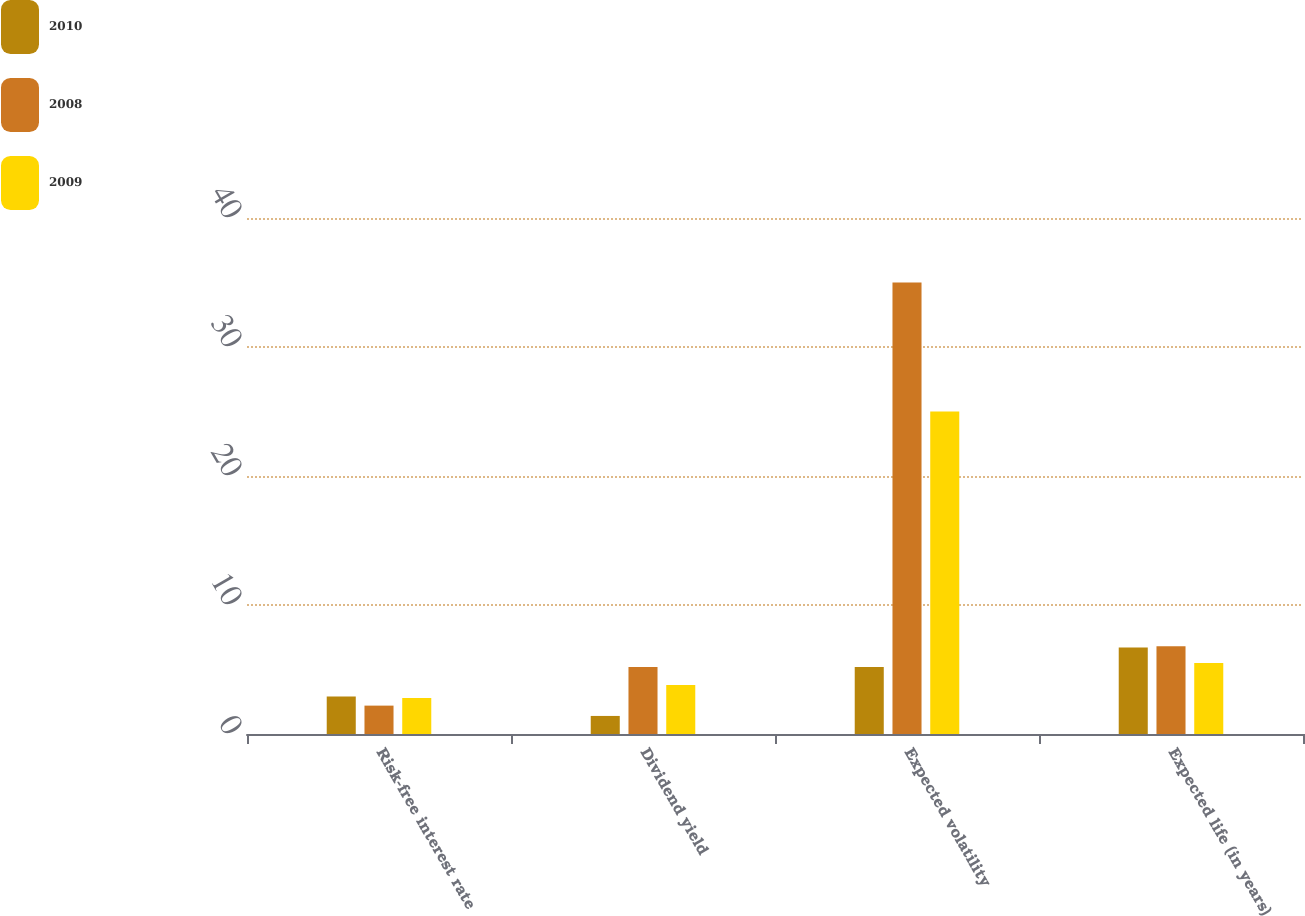Convert chart. <chart><loc_0><loc_0><loc_500><loc_500><stacked_bar_chart><ecel><fcel>Risk-free interest rate<fcel>Dividend yield<fcel>Expected volatility<fcel>Expected life (in years)<nl><fcel>2010<fcel>2.9<fcel>1.4<fcel>5.2<fcel>6.7<nl><fcel>2008<fcel>2.2<fcel>5.2<fcel>35<fcel>6.8<nl><fcel>2009<fcel>2.8<fcel>3.8<fcel>25<fcel>5.5<nl></chart> 